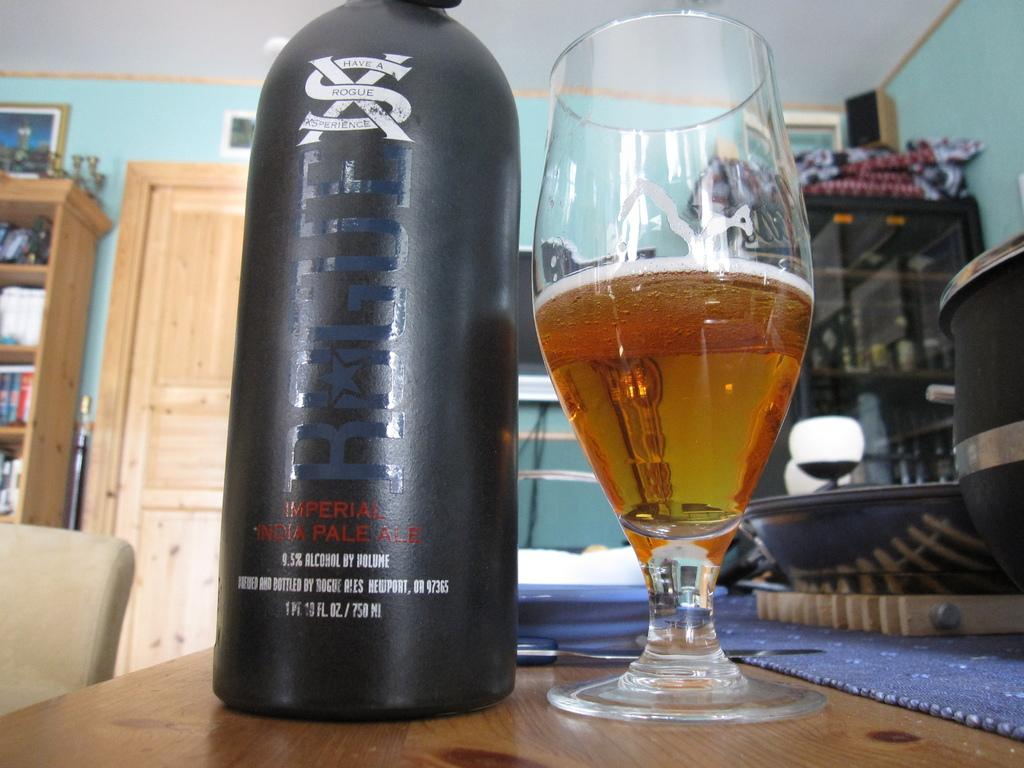<image>
Render a clear and concise summary of the photo. A black container of Imperial Pale Ale next to a glass filled with alcohol. 